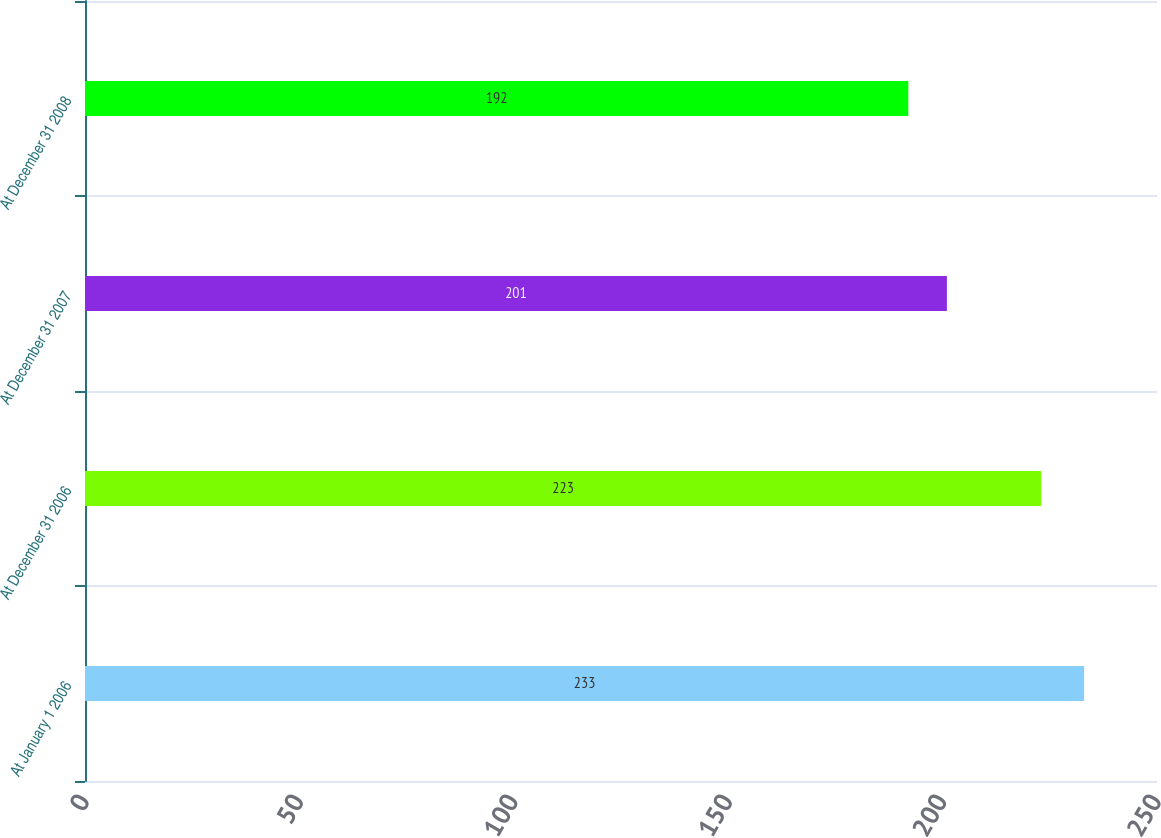Convert chart to OTSL. <chart><loc_0><loc_0><loc_500><loc_500><bar_chart><fcel>At January 1 2006<fcel>At December 31 2006<fcel>At December 31 2007<fcel>At December 31 2008<nl><fcel>233<fcel>223<fcel>201<fcel>192<nl></chart> 